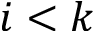Convert formula to latex. <formula><loc_0><loc_0><loc_500><loc_500>i < k</formula> 